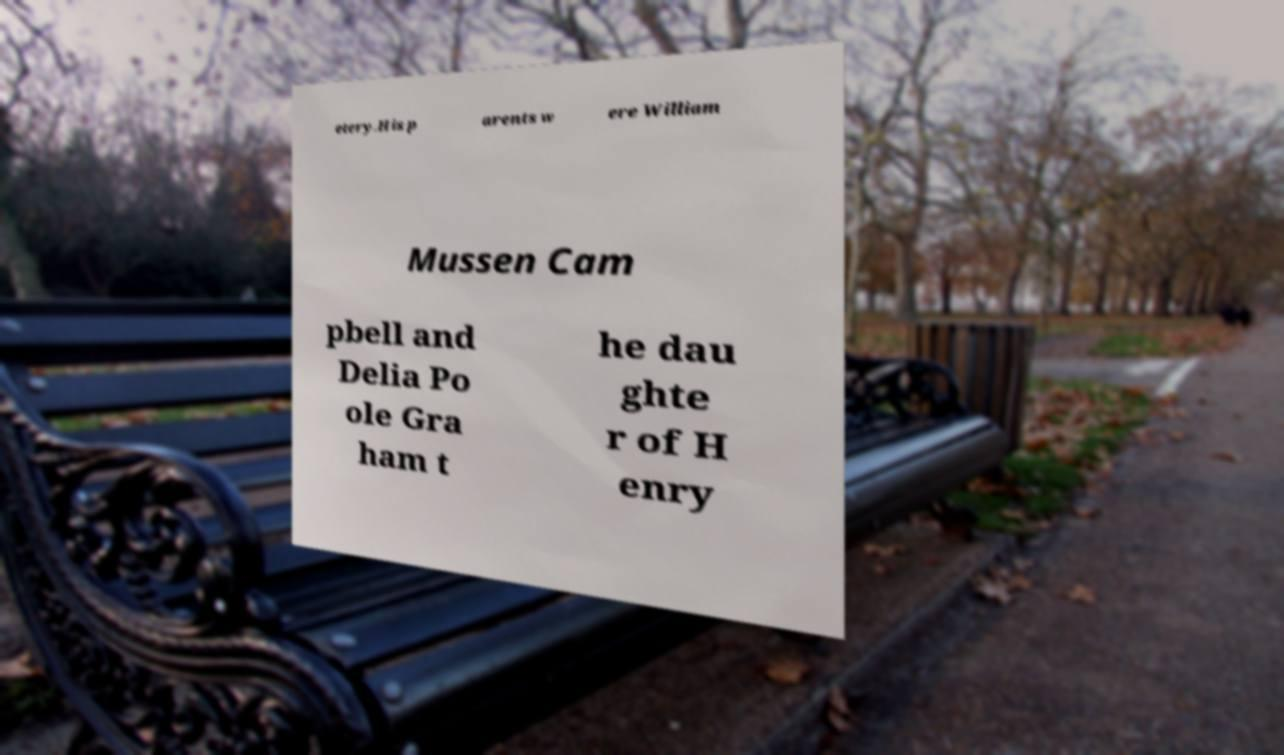Could you assist in decoding the text presented in this image and type it out clearly? etery.His p arents w ere William Mussen Cam pbell and Delia Po ole Gra ham t he dau ghte r of H enry 